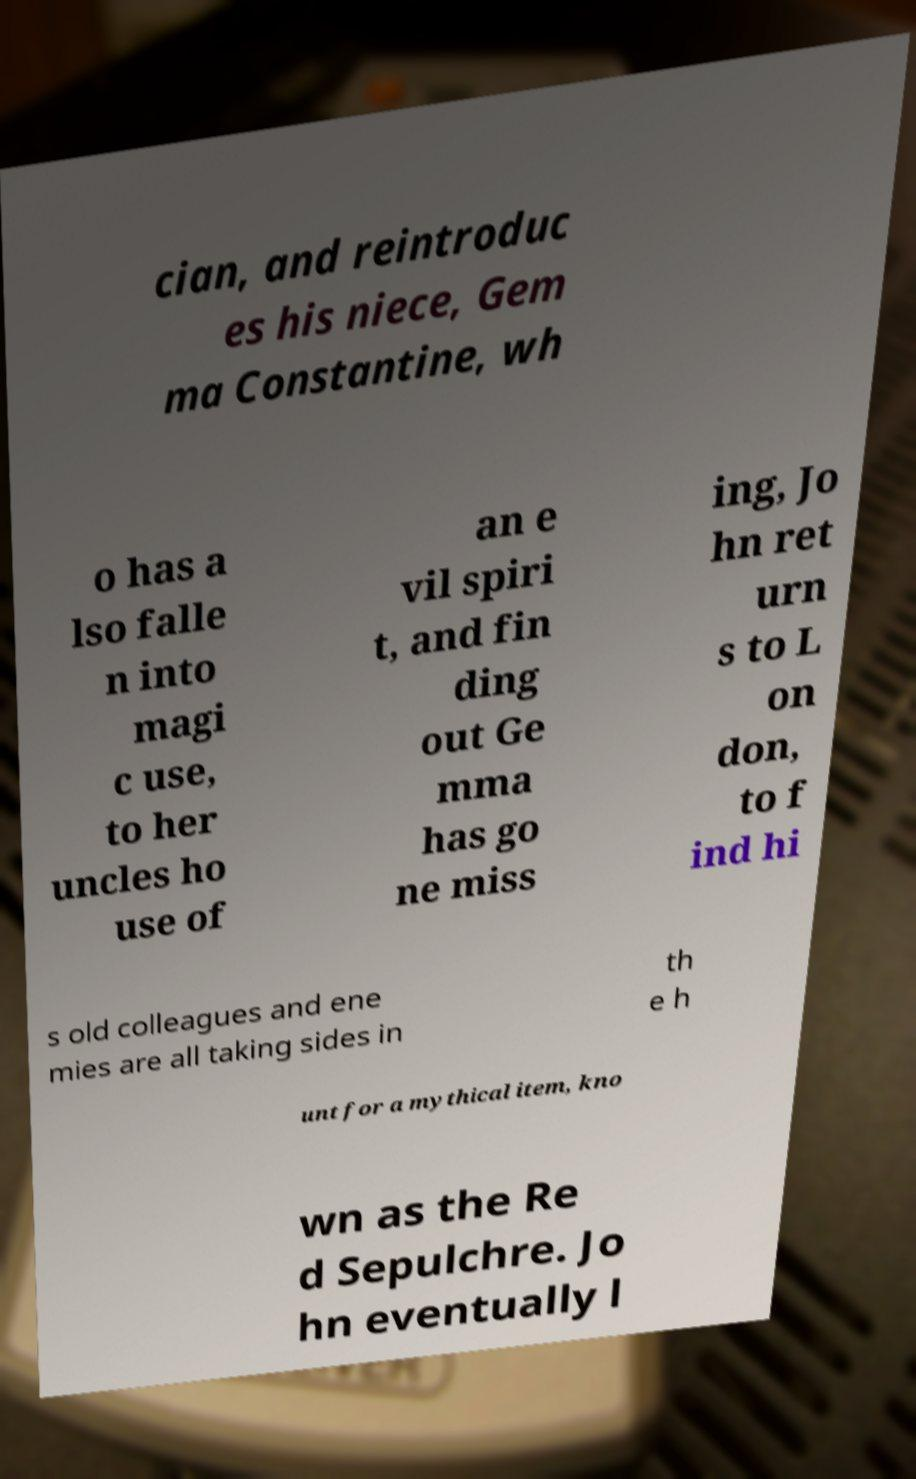Could you assist in decoding the text presented in this image and type it out clearly? cian, and reintroduc es his niece, Gem ma Constantine, wh o has a lso falle n into magi c use, to her uncles ho use of an e vil spiri t, and fin ding out Ge mma has go ne miss ing, Jo hn ret urn s to L on don, to f ind hi s old colleagues and ene mies are all taking sides in th e h unt for a mythical item, kno wn as the Re d Sepulchre. Jo hn eventually l 